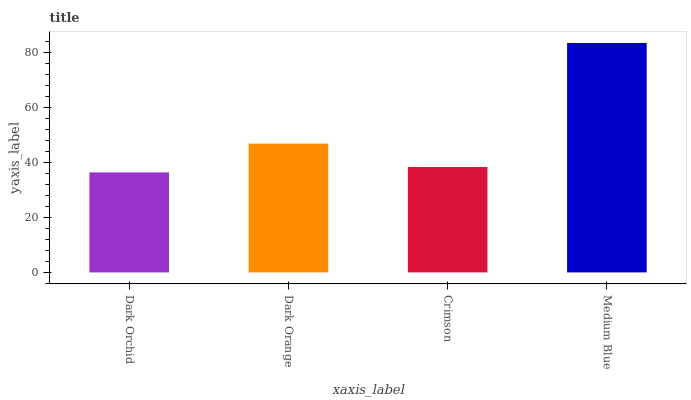Is Dark Orchid the minimum?
Answer yes or no. Yes. Is Medium Blue the maximum?
Answer yes or no. Yes. Is Dark Orange the minimum?
Answer yes or no. No. Is Dark Orange the maximum?
Answer yes or no. No. Is Dark Orange greater than Dark Orchid?
Answer yes or no. Yes. Is Dark Orchid less than Dark Orange?
Answer yes or no. Yes. Is Dark Orchid greater than Dark Orange?
Answer yes or no. No. Is Dark Orange less than Dark Orchid?
Answer yes or no. No. Is Dark Orange the high median?
Answer yes or no. Yes. Is Crimson the low median?
Answer yes or no. Yes. Is Crimson the high median?
Answer yes or no. No. Is Dark Orange the low median?
Answer yes or no. No. 